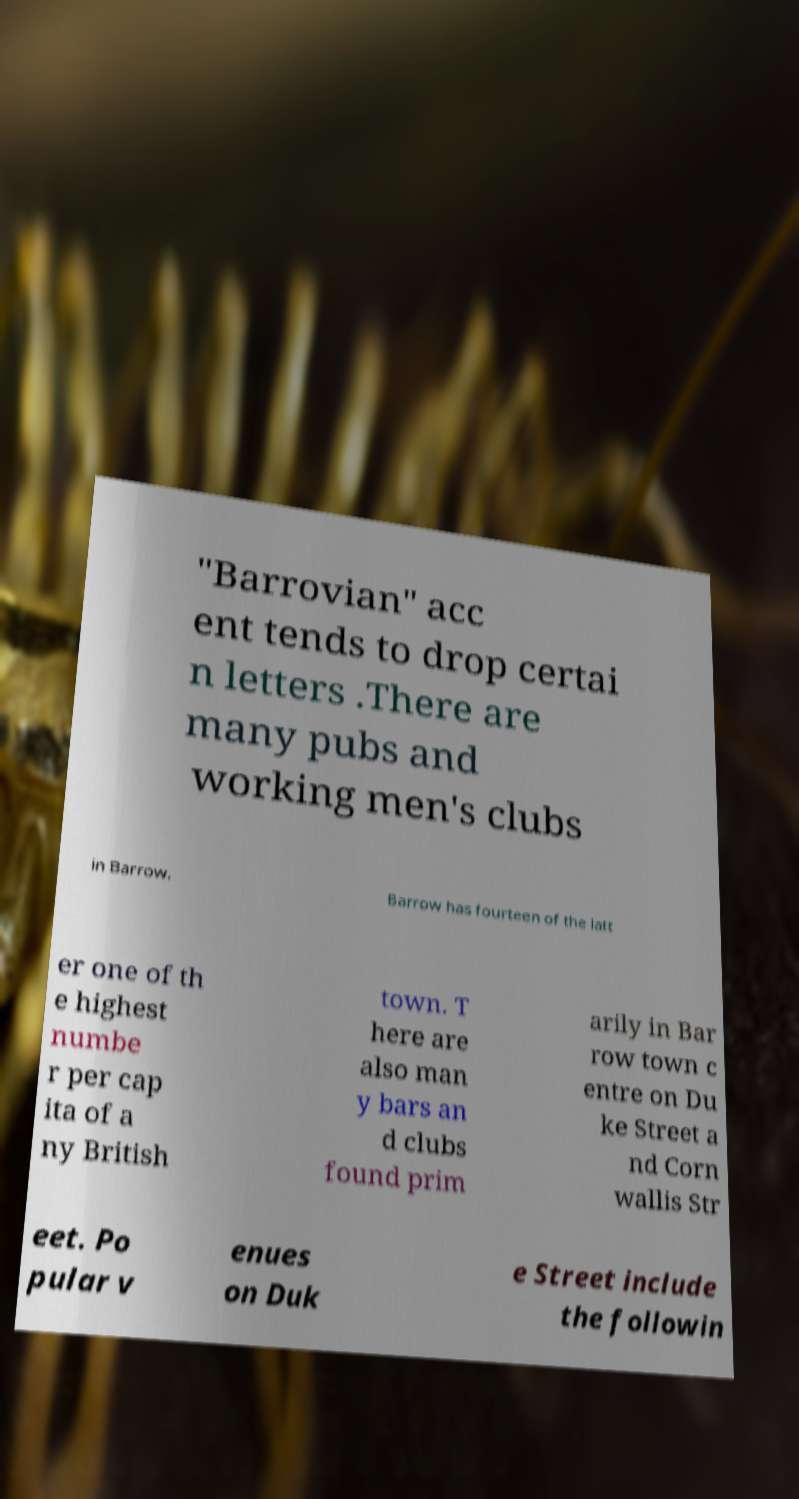There's text embedded in this image that I need extracted. Can you transcribe it verbatim? "Barrovian" acc ent tends to drop certai n letters .There are many pubs and working men's clubs in Barrow. Barrow has fourteen of the latt er one of th e highest numbe r per cap ita of a ny British town. T here are also man y bars an d clubs found prim arily in Bar row town c entre on Du ke Street a nd Corn wallis Str eet. Po pular v enues on Duk e Street include the followin 